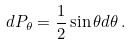Convert formula to latex. <formula><loc_0><loc_0><loc_500><loc_500>d P _ { \theta } = \frac { 1 } { 2 } \sin \theta d \theta \, .</formula> 